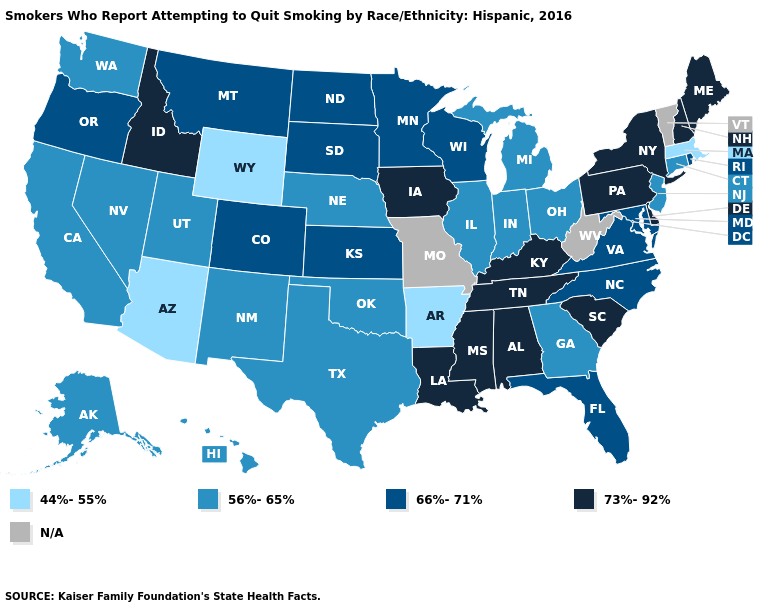What is the lowest value in states that border Kentucky?
Be succinct. 56%-65%. Name the states that have a value in the range 44%-55%?
Answer briefly. Arizona, Arkansas, Massachusetts, Wyoming. What is the highest value in states that border Oklahoma?
Quick response, please. 66%-71%. What is the lowest value in the USA?
Quick response, please. 44%-55%. Name the states that have a value in the range 56%-65%?
Write a very short answer. Alaska, California, Connecticut, Georgia, Hawaii, Illinois, Indiana, Michigan, Nebraska, Nevada, New Jersey, New Mexico, Ohio, Oklahoma, Texas, Utah, Washington. Name the states that have a value in the range 66%-71%?
Answer briefly. Colorado, Florida, Kansas, Maryland, Minnesota, Montana, North Carolina, North Dakota, Oregon, Rhode Island, South Dakota, Virginia, Wisconsin. Name the states that have a value in the range N/A?
Keep it brief. Missouri, Vermont, West Virginia. Does Mississippi have the lowest value in the South?
Answer briefly. No. What is the value of Kansas?
Short answer required. 66%-71%. What is the value of Maine?
Concise answer only. 73%-92%. What is the value of Mississippi?
Be succinct. 73%-92%. What is the lowest value in the MidWest?
Quick response, please. 56%-65%. What is the value of Rhode Island?
Concise answer only. 66%-71%. Name the states that have a value in the range 56%-65%?
Concise answer only. Alaska, California, Connecticut, Georgia, Hawaii, Illinois, Indiana, Michigan, Nebraska, Nevada, New Jersey, New Mexico, Ohio, Oklahoma, Texas, Utah, Washington. What is the value of Nevada?
Give a very brief answer. 56%-65%. 